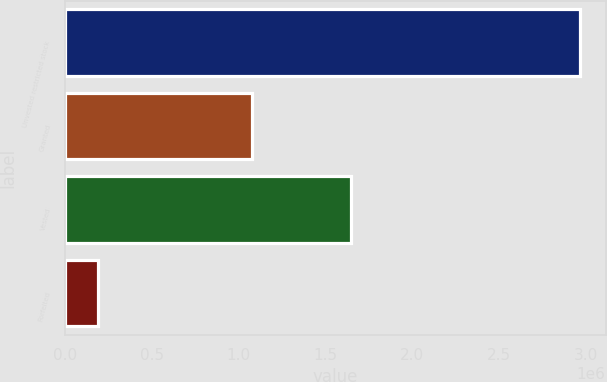<chart> <loc_0><loc_0><loc_500><loc_500><bar_chart><fcel>Unvested restricted stock<fcel>Granted<fcel>Vested<fcel>Forfeited<nl><fcel>2.96471e+06<fcel>1.07895e+06<fcel>1.64829e+06<fcel>188499<nl></chart> 